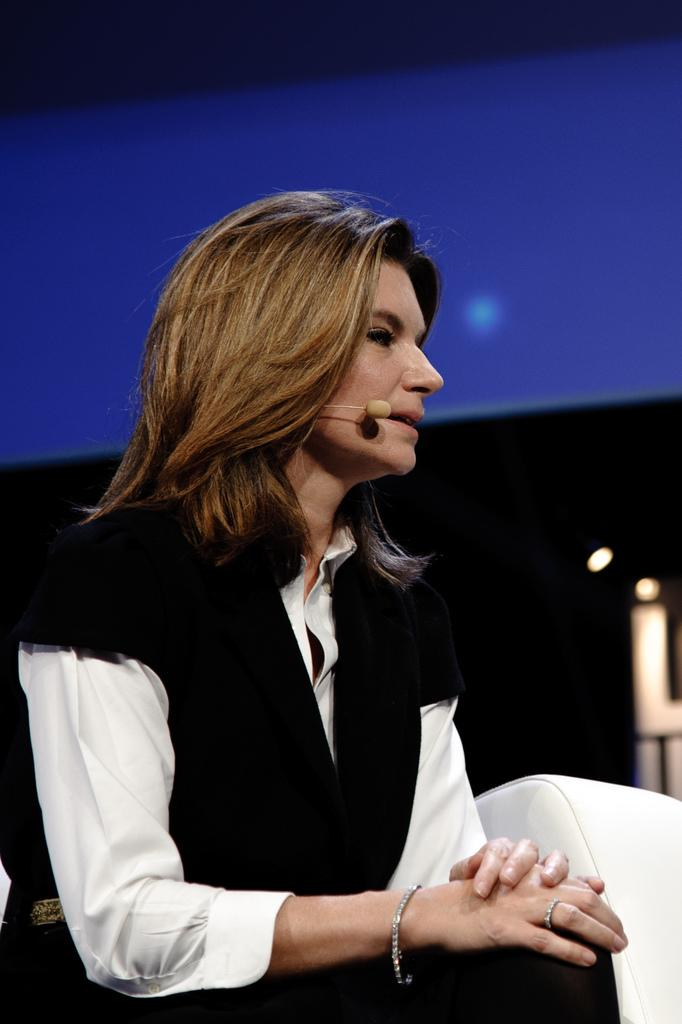Who is the main subject in the image? There is a woman in the image. What is the woman wearing? The woman is wearing a black and white dress. What is the woman doing in the image? The woman is sitting in a chair. What can be observed about the background of the image? The background of the image is dark. Can you see a snake slithering across the floor in the image? There is no snake present in the image. 